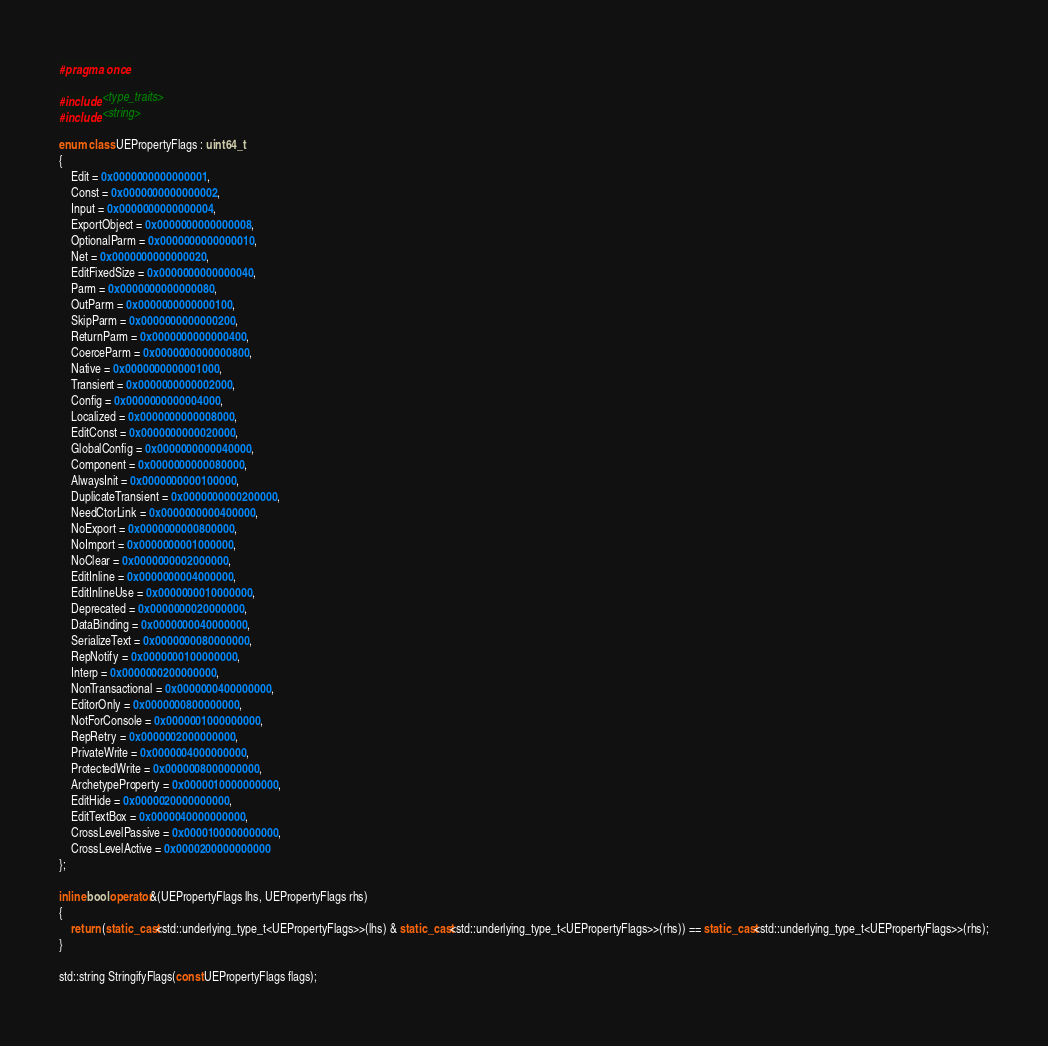Convert code to text. <code><loc_0><loc_0><loc_500><loc_500><_C++_>#pragma once

#include <type_traits>
#include <string>

enum class UEPropertyFlags : uint64_t
{
	Edit = 0x0000000000000001,
	Const = 0x0000000000000002,
	Input = 0x0000000000000004,
	ExportObject = 0x0000000000000008,
	OptionalParm = 0x0000000000000010,
	Net = 0x0000000000000020,
	EditFixedSize = 0x0000000000000040,
	Parm = 0x0000000000000080,
	OutParm = 0x0000000000000100,
	SkipParm = 0x0000000000000200,
	ReturnParm = 0x0000000000000400,
	CoerceParm = 0x0000000000000800,
	Native = 0x0000000000001000,
	Transient = 0x0000000000002000,
	Config = 0x0000000000004000,
	Localized = 0x0000000000008000,
	EditConst = 0x0000000000020000,
	GlobalConfig = 0x0000000000040000,
	Component = 0x0000000000080000,
	AlwaysInit = 0x0000000000100000,
	DuplicateTransient = 0x0000000000200000,
	NeedCtorLink = 0x0000000000400000,
	NoExport = 0x0000000000800000,
	NoImport = 0x0000000001000000,
	NoClear = 0x0000000002000000,
	EditInline = 0x0000000004000000,
	EditInlineUse = 0x0000000010000000,
	Deprecated = 0x0000000020000000,
	DataBinding = 0x0000000040000000,
	SerializeText = 0x0000000080000000,
	RepNotify = 0x0000000100000000,
	Interp = 0x0000000200000000,
	NonTransactional = 0x0000000400000000,
	EditorOnly = 0x0000000800000000,
	NotForConsole = 0x0000001000000000,
	RepRetry = 0x0000002000000000,
	PrivateWrite = 0x0000004000000000,
	ProtectedWrite = 0x0000008000000000,
	ArchetypeProperty = 0x0000010000000000,
	EditHide = 0x0000020000000000,
	EditTextBox = 0x0000040000000000,
	CrossLevelPassive = 0x0000100000000000,
	CrossLevelActive = 0x0000200000000000
};

inline bool operator&(UEPropertyFlags lhs, UEPropertyFlags rhs)
{
	return (static_cast<std::underlying_type_t<UEPropertyFlags>>(lhs) & static_cast<std::underlying_type_t<UEPropertyFlags>>(rhs)) == static_cast<std::underlying_type_t<UEPropertyFlags>>(rhs);
}

std::string StringifyFlags(const UEPropertyFlags flags);</code> 